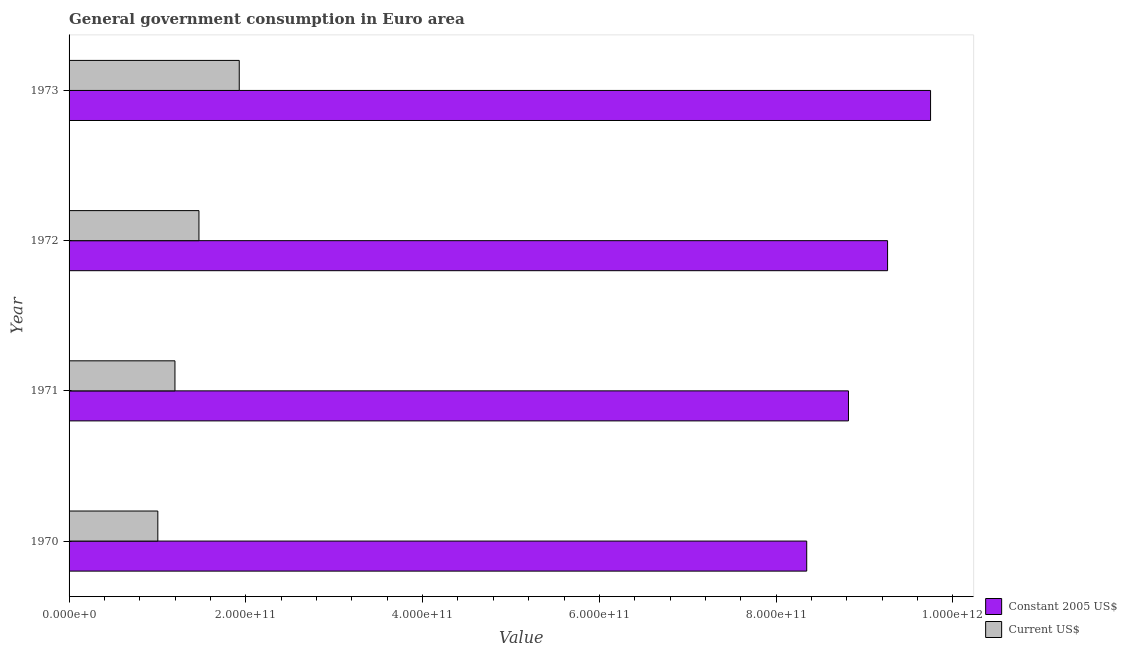How many different coloured bars are there?
Your answer should be compact. 2. How many groups of bars are there?
Offer a very short reply. 4. Are the number of bars per tick equal to the number of legend labels?
Give a very brief answer. Yes. How many bars are there on the 3rd tick from the bottom?
Make the answer very short. 2. What is the label of the 2nd group of bars from the top?
Keep it short and to the point. 1972. In how many cases, is the number of bars for a given year not equal to the number of legend labels?
Offer a very short reply. 0. What is the value consumed in constant 2005 us$ in 1971?
Make the answer very short. 8.82e+11. Across all years, what is the maximum value consumed in constant 2005 us$?
Provide a succinct answer. 9.75e+11. Across all years, what is the minimum value consumed in constant 2005 us$?
Ensure brevity in your answer.  8.35e+11. In which year was the value consumed in current us$ maximum?
Offer a very short reply. 1973. In which year was the value consumed in current us$ minimum?
Keep it short and to the point. 1970. What is the total value consumed in constant 2005 us$ in the graph?
Make the answer very short. 3.62e+12. What is the difference between the value consumed in current us$ in 1972 and that in 1973?
Ensure brevity in your answer.  -4.56e+1. What is the difference between the value consumed in constant 2005 us$ in 1971 and the value consumed in current us$ in 1970?
Make the answer very short. 7.81e+11. What is the average value consumed in constant 2005 us$ per year?
Your answer should be very brief. 9.04e+11. In the year 1970, what is the difference between the value consumed in current us$ and value consumed in constant 2005 us$?
Keep it short and to the point. -7.34e+11. In how many years, is the value consumed in constant 2005 us$ greater than 320000000000 ?
Your answer should be very brief. 4. What is the ratio of the value consumed in current us$ in 1970 to that in 1973?
Provide a short and direct response. 0.52. Is the difference between the value consumed in current us$ in 1971 and 1972 greater than the difference between the value consumed in constant 2005 us$ in 1971 and 1972?
Your response must be concise. Yes. What is the difference between the highest and the second highest value consumed in current us$?
Give a very brief answer. 4.56e+1. What is the difference between the highest and the lowest value consumed in current us$?
Your answer should be very brief. 9.21e+1. In how many years, is the value consumed in constant 2005 us$ greater than the average value consumed in constant 2005 us$ taken over all years?
Your answer should be very brief. 2. Is the sum of the value consumed in constant 2005 us$ in 1970 and 1973 greater than the maximum value consumed in current us$ across all years?
Your answer should be compact. Yes. What does the 2nd bar from the top in 1970 represents?
Your answer should be very brief. Constant 2005 US$. What does the 2nd bar from the bottom in 1971 represents?
Provide a succinct answer. Current US$. How many bars are there?
Ensure brevity in your answer.  8. Are all the bars in the graph horizontal?
Give a very brief answer. Yes. How many years are there in the graph?
Offer a very short reply. 4. What is the difference between two consecutive major ticks on the X-axis?
Provide a short and direct response. 2.00e+11. Are the values on the major ticks of X-axis written in scientific E-notation?
Offer a terse response. Yes. Where does the legend appear in the graph?
Give a very brief answer. Bottom right. What is the title of the graph?
Provide a short and direct response. General government consumption in Euro area. What is the label or title of the X-axis?
Offer a very short reply. Value. What is the Value in Constant 2005 US$ in 1970?
Keep it short and to the point. 8.35e+11. What is the Value of Current US$ in 1970?
Your answer should be very brief. 1.00e+11. What is the Value of Constant 2005 US$ in 1971?
Provide a short and direct response. 8.82e+11. What is the Value in Current US$ in 1971?
Offer a terse response. 1.20e+11. What is the Value of Constant 2005 US$ in 1972?
Your answer should be very brief. 9.26e+11. What is the Value in Current US$ in 1972?
Provide a short and direct response. 1.47e+11. What is the Value of Constant 2005 US$ in 1973?
Your answer should be compact. 9.75e+11. What is the Value of Current US$ in 1973?
Offer a very short reply. 1.93e+11. Across all years, what is the maximum Value of Constant 2005 US$?
Your response must be concise. 9.75e+11. Across all years, what is the maximum Value in Current US$?
Your response must be concise. 1.93e+11. Across all years, what is the minimum Value of Constant 2005 US$?
Offer a terse response. 8.35e+11. Across all years, what is the minimum Value of Current US$?
Give a very brief answer. 1.00e+11. What is the total Value in Constant 2005 US$ in the graph?
Make the answer very short. 3.62e+12. What is the total Value in Current US$ in the graph?
Make the answer very short. 5.60e+11. What is the difference between the Value in Constant 2005 US$ in 1970 and that in 1971?
Ensure brevity in your answer.  -4.72e+1. What is the difference between the Value of Current US$ in 1970 and that in 1971?
Your response must be concise. -1.94e+1. What is the difference between the Value in Constant 2005 US$ in 1970 and that in 1972?
Your answer should be very brief. -9.15e+1. What is the difference between the Value of Current US$ in 1970 and that in 1972?
Provide a short and direct response. -4.65e+1. What is the difference between the Value in Constant 2005 US$ in 1970 and that in 1973?
Your answer should be very brief. -1.40e+11. What is the difference between the Value of Current US$ in 1970 and that in 1973?
Provide a short and direct response. -9.21e+1. What is the difference between the Value in Constant 2005 US$ in 1971 and that in 1972?
Offer a terse response. -4.43e+1. What is the difference between the Value in Current US$ in 1971 and that in 1972?
Make the answer very short. -2.72e+1. What is the difference between the Value in Constant 2005 US$ in 1971 and that in 1973?
Your answer should be compact. -9.29e+1. What is the difference between the Value in Current US$ in 1971 and that in 1973?
Give a very brief answer. -7.27e+1. What is the difference between the Value of Constant 2005 US$ in 1972 and that in 1973?
Ensure brevity in your answer.  -4.86e+1. What is the difference between the Value in Current US$ in 1972 and that in 1973?
Your response must be concise. -4.56e+1. What is the difference between the Value of Constant 2005 US$ in 1970 and the Value of Current US$ in 1971?
Your answer should be compact. 7.15e+11. What is the difference between the Value of Constant 2005 US$ in 1970 and the Value of Current US$ in 1972?
Offer a very short reply. 6.88e+11. What is the difference between the Value of Constant 2005 US$ in 1970 and the Value of Current US$ in 1973?
Make the answer very short. 6.42e+11. What is the difference between the Value of Constant 2005 US$ in 1971 and the Value of Current US$ in 1972?
Provide a short and direct response. 7.35e+11. What is the difference between the Value of Constant 2005 US$ in 1971 and the Value of Current US$ in 1973?
Provide a short and direct response. 6.89e+11. What is the difference between the Value in Constant 2005 US$ in 1972 and the Value in Current US$ in 1973?
Your answer should be compact. 7.34e+11. What is the average Value of Constant 2005 US$ per year?
Keep it short and to the point. 9.04e+11. What is the average Value in Current US$ per year?
Your answer should be compact. 1.40e+11. In the year 1970, what is the difference between the Value in Constant 2005 US$ and Value in Current US$?
Keep it short and to the point. 7.34e+11. In the year 1971, what is the difference between the Value of Constant 2005 US$ and Value of Current US$?
Make the answer very short. 7.62e+11. In the year 1972, what is the difference between the Value of Constant 2005 US$ and Value of Current US$?
Your response must be concise. 7.79e+11. In the year 1973, what is the difference between the Value of Constant 2005 US$ and Value of Current US$?
Offer a terse response. 7.82e+11. What is the ratio of the Value in Constant 2005 US$ in 1970 to that in 1971?
Give a very brief answer. 0.95. What is the ratio of the Value of Current US$ in 1970 to that in 1971?
Offer a terse response. 0.84. What is the ratio of the Value of Constant 2005 US$ in 1970 to that in 1972?
Your answer should be very brief. 0.9. What is the ratio of the Value in Current US$ in 1970 to that in 1972?
Give a very brief answer. 0.68. What is the ratio of the Value in Constant 2005 US$ in 1970 to that in 1973?
Your answer should be very brief. 0.86. What is the ratio of the Value of Current US$ in 1970 to that in 1973?
Ensure brevity in your answer.  0.52. What is the ratio of the Value in Constant 2005 US$ in 1971 to that in 1972?
Your response must be concise. 0.95. What is the ratio of the Value of Current US$ in 1971 to that in 1972?
Your response must be concise. 0.82. What is the ratio of the Value in Constant 2005 US$ in 1971 to that in 1973?
Your answer should be very brief. 0.9. What is the ratio of the Value in Current US$ in 1971 to that in 1973?
Give a very brief answer. 0.62. What is the ratio of the Value in Constant 2005 US$ in 1972 to that in 1973?
Your response must be concise. 0.95. What is the ratio of the Value of Current US$ in 1972 to that in 1973?
Make the answer very short. 0.76. What is the difference between the highest and the second highest Value in Constant 2005 US$?
Provide a succinct answer. 4.86e+1. What is the difference between the highest and the second highest Value in Current US$?
Your response must be concise. 4.56e+1. What is the difference between the highest and the lowest Value of Constant 2005 US$?
Your answer should be very brief. 1.40e+11. What is the difference between the highest and the lowest Value of Current US$?
Offer a very short reply. 9.21e+1. 